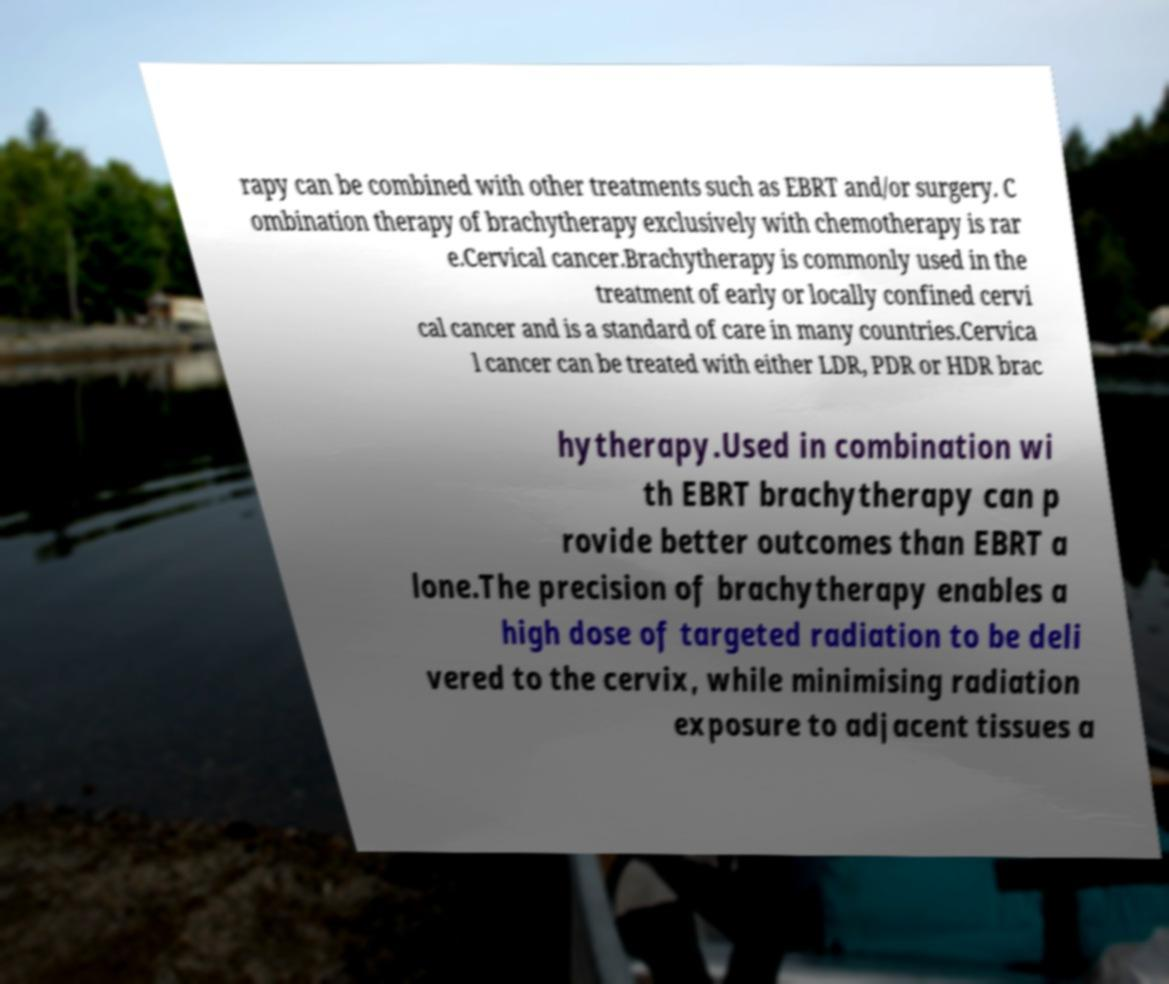Could you assist in decoding the text presented in this image and type it out clearly? rapy can be combined with other treatments such as EBRT and/or surgery. C ombination therapy of brachytherapy exclusively with chemotherapy is rar e.Cervical cancer.Brachytherapy is commonly used in the treatment of early or locally confined cervi cal cancer and is a standard of care in many countries.Cervica l cancer can be treated with either LDR, PDR or HDR brac hytherapy.Used in combination wi th EBRT brachytherapy can p rovide better outcomes than EBRT a lone.The precision of brachytherapy enables a high dose of targeted radiation to be deli vered to the cervix, while minimising radiation exposure to adjacent tissues a 